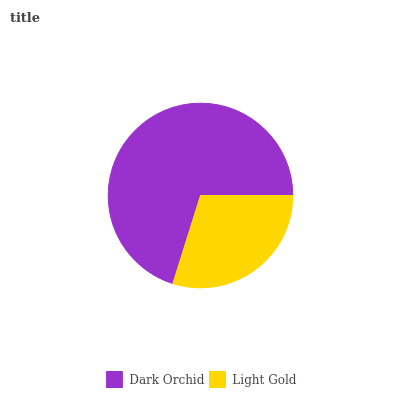Is Light Gold the minimum?
Answer yes or no. Yes. Is Dark Orchid the maximum?
Answer yes or no. Yes. Is Light Gold the maximum?
Answer yes or no. No. Is Dark Orchid greater than Light Gold?
Answer yes or no. Yes. Is Light Gold less than Dark Orchid?
Answer yes or no. Yes. Is Light Gold greater than Dark Orchid?
Answer yes or no. No. Is Dark Orchid less than Light Gold?
Answer yes or no. No. Is Dark Orchid the high median?
Answer yes or no. Yes. Is Light Gold the low median?
Answer yes or no. Yes. Is Light Gold the high median?
Answer yes or no. No. Is Dark Orchid the low median?
Answer yes or no. No. 